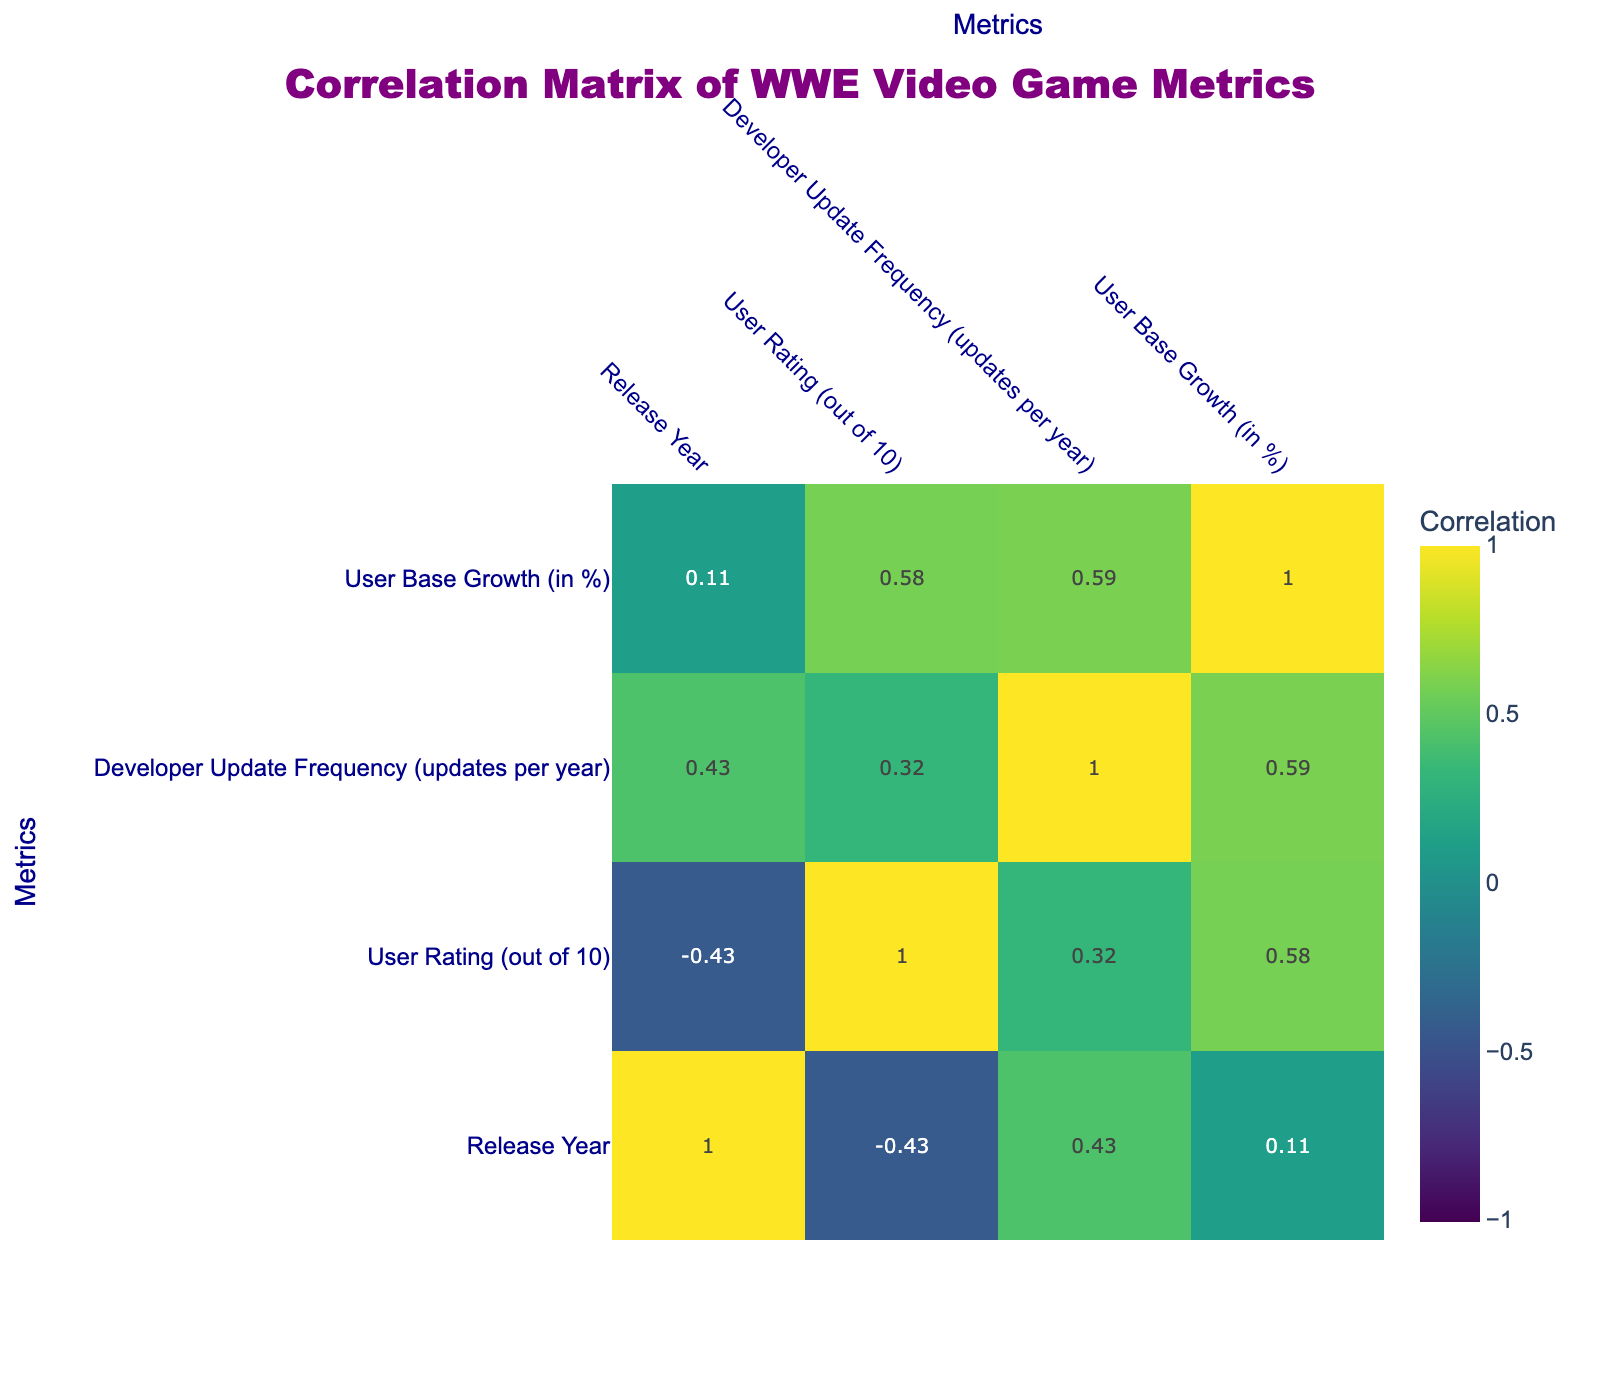What is the user rating of WWE 2K20? The user rating for WWE 2K20 is listed in the table under the "User Rating (out of 10)" column. It shows a rating of 4.0.
Answer: 4.0 Which game has the highest user rating? By scanning the "User Rating (out of 10)" column, I can see that WWE 2K16 has the highest user rating at 9.0.
Answer: WWE 2K16 Is there a correlation between Developer Update Frequency and User Rating? To determine this, I look at the correlation value in the table. If it is close to 1 or -1, it indicates a strong relationship, while values near 0 indicate no relationship. The correlation value for Developer Update Frequency and User Rating shows a positive relationship.
Answer: Yes Which game had the most major features introduced? The table lists the major features introduced for each game. WWE 2K14 stands out with "30 Years of WrestleMania mode," which is quite significant compared to others. This indicates it had a key set of features.
Answer: WWE 2K14 What is the average user rating for games released after 2017? I first identify the user ratings of games released after 2017: WWE 2K18 (8.2), WWE 2K19 (8.5), WWE 2K20 (4.0), and WWE 2K Battlegrounds (7.5). Adding these ratings (8.2 + 8.5 + 4.0 + 7.5 = 28.2) gives a total of 28.2. Dividing by the number of games (4) gives the average as 28.2 / 4 = 7.05.
Answer: 7.05 Is WWE All Stars more popular based on user ratings compared to WWE 2K Battlegrounds? Comparing the user ratings from the two games: WWE All Stars has a user rating of 8.0, while WWE 2K Battlegrounds has a rating of 7.5. Since 8.0 is greater than 7.5, All Stars is indeed more popular based on the ratings.
Answer: Yes What is the percentage increase in user base for WWE 2K19 compared to WWE 2K20? I subtract the user base growth percentage of WWE 2K20 (5%) from that of WWE 2K19 (12%) to find the difference. 12% - 5% = 7%. This indicates an increase of 7% in user base growth for WWE 2K19 compared to WWE 2K20.
Answer: 7% increase Which game had both the highest user rating and developer update frequency? Analyzing the data, WWE 2K16 has a user rating of 9.0 and a developer update frequency of 2 updates per year. Looking across the table, none of the other games surpass both metrics. Thus, WWE 2K16 matches the criteria of being highest in both categories.
Answer: WWE 2K16 Is there any game that received a user rating of 9.0 or above? Looking through the "User Rating (out of 10)" column, I find WWE 2K14 (9.2) and WWE 2K16 (9.0), both of which exceed the 9.0 threshold. Therefore, there are two games falling under this category.
Answer: Yes 